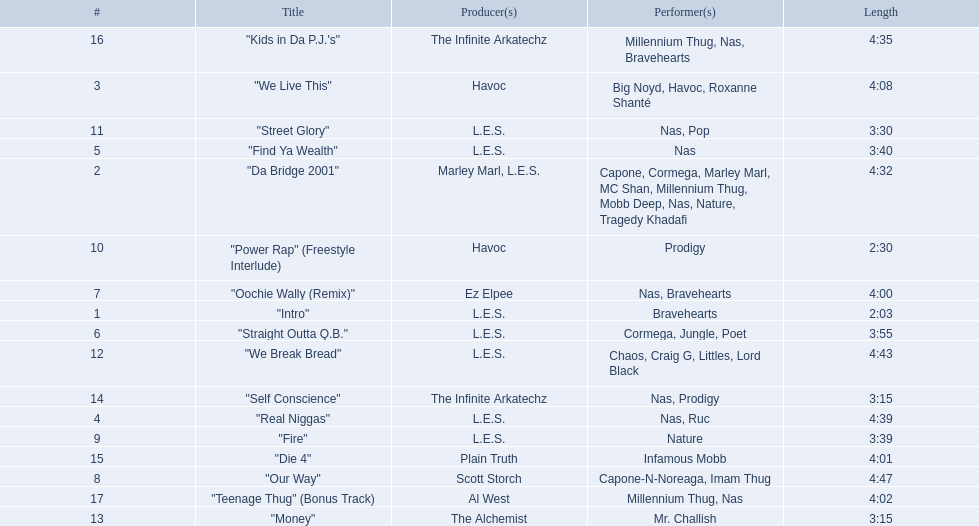How long is each song? 2:03, 4:32, 4:08, 4:39, 3:40, 3:55, 4:00, 4:47, 3:39, 2:30, 3:30, 4:43, 3:15, 3:15, 4:01, 4:35, 4:02. Of those, which length is the shortest? 2:03. 